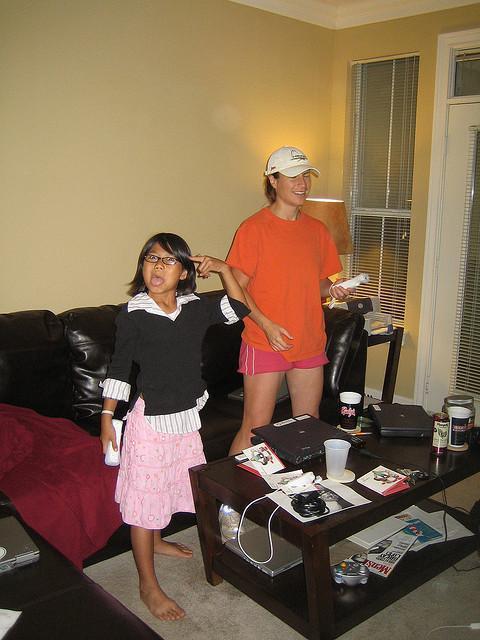What is the girl pointing to?
Select the correct answer and articulate reasoning with the following format: 'Answer: answer
Rationale: rationale.'
Options: Elbow, head, knee, foot. Answer: head.
Rationale: The girl is holding a finger to her temple. 